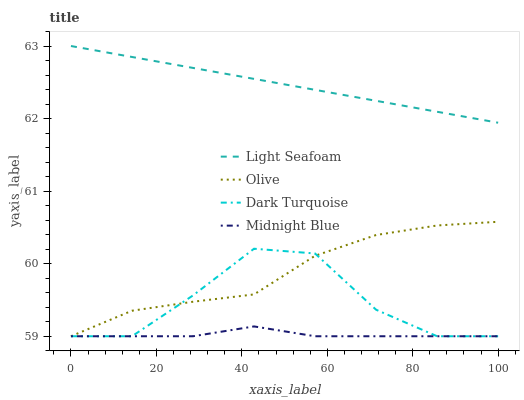Does Midnight Blue have the minimum area under the curve?
Answer yes or no. Yes. Does Light Seafoam have the maximum area under the curve?
Answer yes or no. Yes. Does Dark Turquoise have the minimum area under the curve?
Answer yes or no. No. Does Dark Turquoise have the maximum area under the curve?
Answer yes or no. No. Is Light Seafoam the smoothest?
Answer yes or no. Yes. Is Dark Turquoise the roughest?
Answer yes or no. Yes. Is Dark Turquoise the smoothest?
Answer yes or no. No. Is Light Seafoam the roughest?
Answer yes or no. No. Does Olive have the lowest value?
Answer yes or no. Yes. Does Light Seafoam have the lowest value?
Answer yes or no. No. Does Light Seafoam have the highest value?
Answer yes or no. Yes. Does Dark Turquoise have the highest value?
Answer yes or no. No. Is Olive less than Light Seafoam?
Answer yes or no. Yes. Is Light Seafoam greater than Midnight Blue?
Answer yes or no. Yes. Does Dark Turquoise intersect Midnight Blue?
Answer yes or no. Yes. Is Dark Turquoise less than Midnight Blue?
Answer yes or no. No. Is Dark Turquoise greater than Midnight Blue?
Answer yes or no. No. Does Olive intersect Light Seafoam?
Answer yes or no. No. 